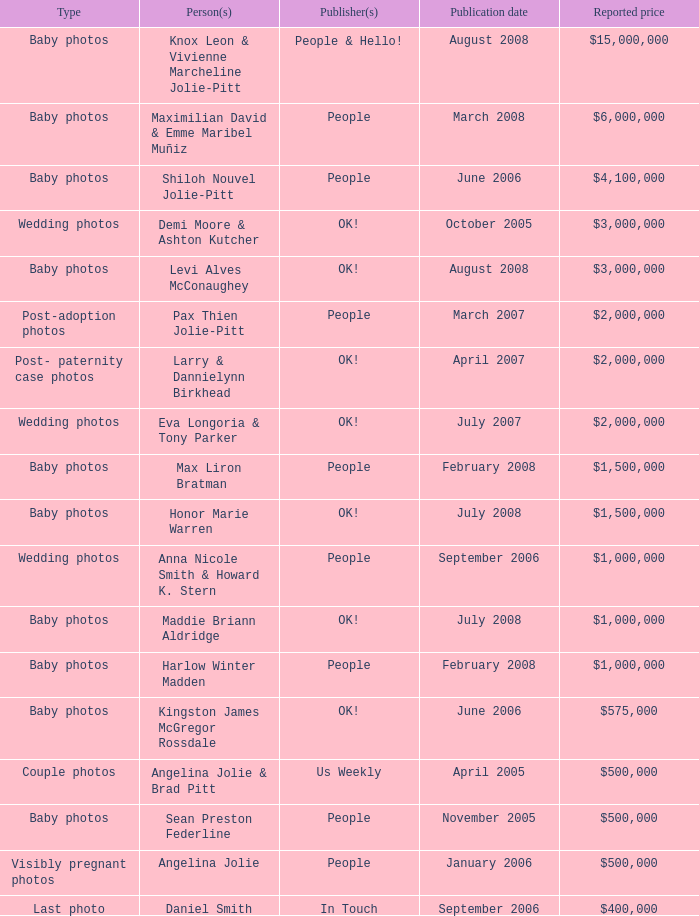When were the $500,000 sean preston federline photos published by people magazine? November 2005. 